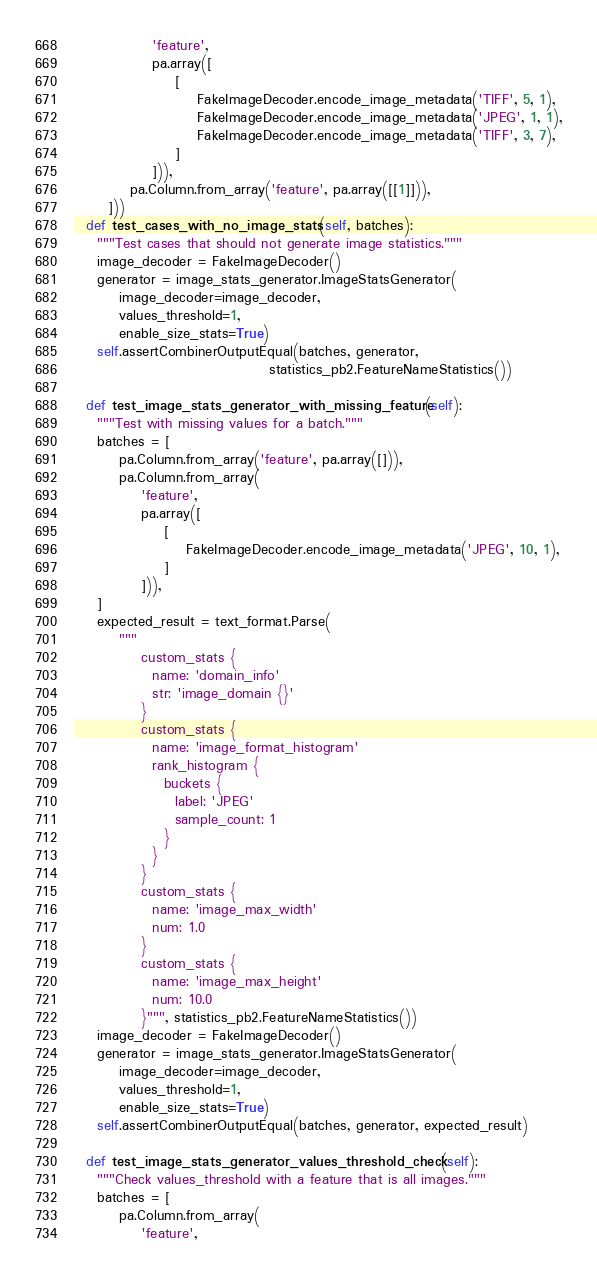<code> <loc_0><loc_0><loc_500><loc_500><_Python_>              'feature',
              pa.array([
                  [
                      FakeImageDecoder.encode_image_metadata('TIFF', 5, 1),
                      FakeImageDecoder.encode_image_metadata('JPEG', 1, 1),
                      FakeImageDecoder.encode_image_metadata('TIFF', 3, 7),
                  ]
              ])),
          pa.Column.from_array('feature', pa.array([[1]])),
      ]))
  def test_cases_with_no_image_stats(self, batches):
    """Test cases that should not generate image statistics."""
    image_decoder = FakeImageDecoder()
    generator = image_stats_generator.ImageStatsGenerator(
        image_decoder=image_decoder,
        values_threshold=1,
        enable_size_stats=True)
    self.assertCombinerOutputEqual(batches, generator,
                                   statistics_pb2.FeatureNameStatistics())

  def test_image_stats_generator_with_missing_feature(self):
    """Test with missing values for a batch."""
    batches = [
        pa.Column.from_array('feature', pa.array([])),
        pa.Column.from_array(
            'feature',
            pa.array([
                [
                    FakeImageDecoder.encode_image_metadata('JPEG', 10, 1),
                ]
            ])),
    ]
    expected_result = text_format.Parse(
        """
            custom_stats {
              name: 'domain_info'
              str: 'image_domain {}'
            }
            custom_stats {
              name: 'image_format_histogram'
              rank_histogram {
                buckets {
                  label: 'JPEG'
                  sample_count: 1
                }
              }
            }
            custom_stats {
              name: 'image_max_width'
              num: 1.0
            }
            custom_stats {
              name: 'image_max_height'
              num: 10.0
            }""", statistics_pb2.FeatureNameStatistics())
    image_decoder = FakeImageDecoder()
    generator = image_stats_generator.ImageStatsGenerator(
        image_decoder=image_decoder,
        values_threshold=1,
        enable_size_stats=True)
    self.assertCombinerOutputEqual(batches, generator, expected_result)

  def test_image_stats_generator_values_threshold_check(self):
    """Check values_threshold with a feature that is all images."""
    batches = [
        pa.Column.from_array(
            'feature',</code> 